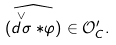Convert formula to latex. <formula><loc_0><loc_0><loc_500><loc_500>\widehat { ( \stackrel { \vee } { d \sigma } \ast \varphi ) } \in { \mathcal { O } } ^ { \prime } _ { C } .</formula> 